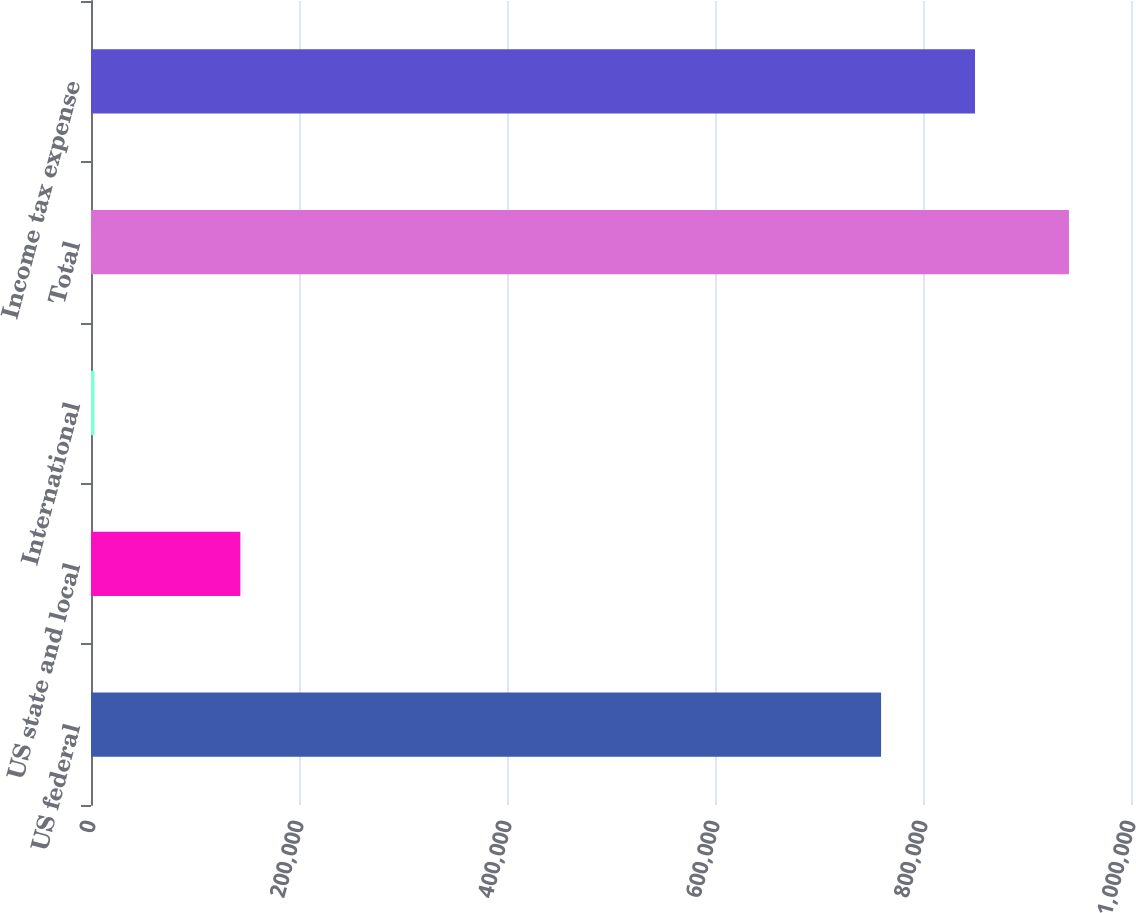Convert chart to OTSL. <chart><loc_0><loc_0><loc_500><loc_500><bar_chart><fcel>US federal<fcel>US state and local<fcel>International<fcel>Total<fcel>Income tax expense<nl><fcel>759683<fcel>143610<fcel>3415<fcel>940342<fcel>850012<nl></chart> 